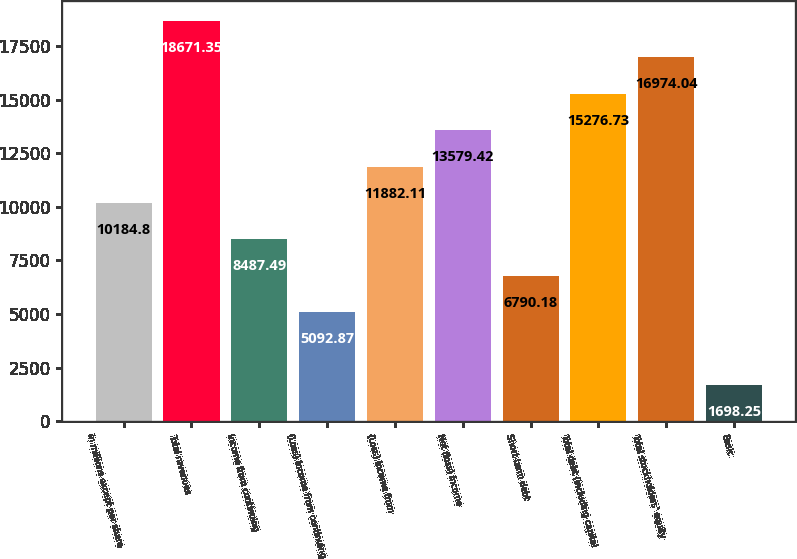Convert chart. <chart><loc_0><loc_0><loc_500><loc_500><bar_chart><fcel>in millions except per share<fcel>Total revenues<fcel>Income from continuing<fcel>(Loss) Income from continuing<fcel>(Loss) Income from<fcel>Net (loss) income<fcel>Short-term debt<fcel>Total debt (including capital<fcel>Total stockholders' equity<fcel>Basic<nl><fcel>10184.8<fcel>18671.3<fcel>8487.49<fcel>5092.87<fcel>11882.1<fcel>13579.4<fcel>6790.18<fcel>15276.7<fcel>16974<fcel>1698.25<nl></chart> 